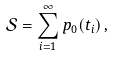Convert formula to latex. <formula><loc_0><loc_0><loc_500><loc_500>\mathcal { S } = \sum _ { i = 1 } ^ { \infty } p _ { 0 } ( t _ { i } ) \, ,</formula> 